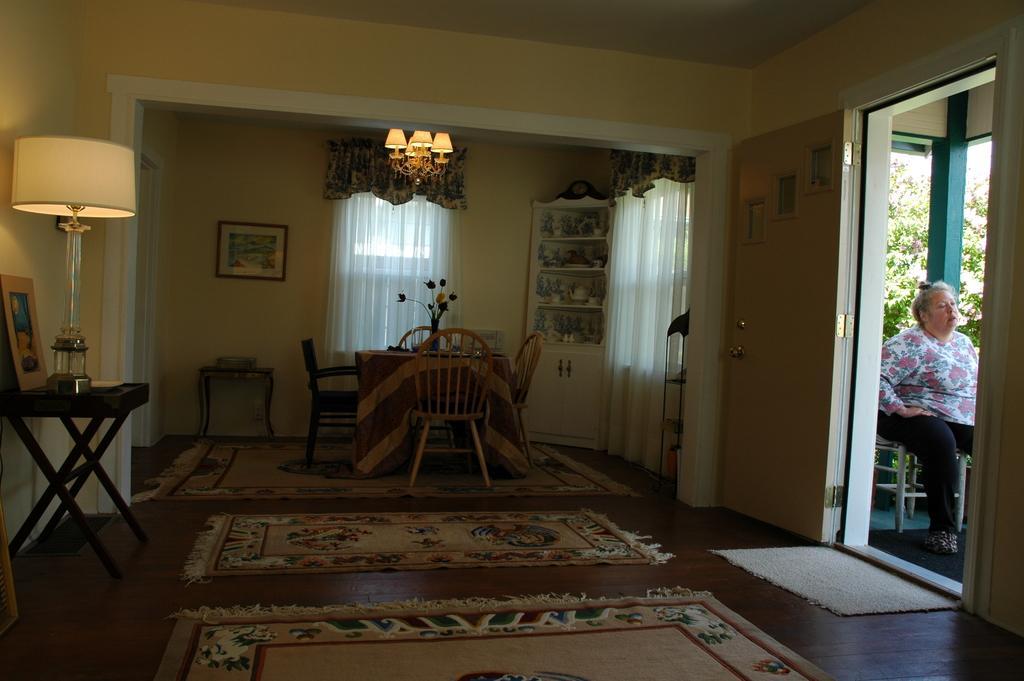Can you describe this image briefly? In this image I can see a room with dining table,lamp and the frames attached to the wall. To the right there is a person sitting on the chair. At the back there are some trees. 